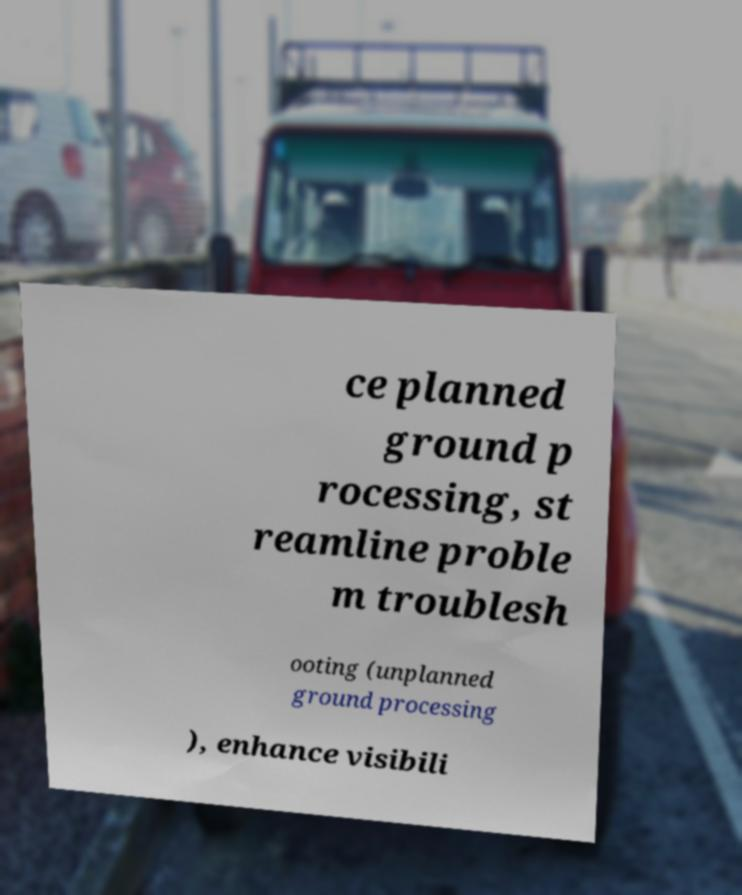What messages or text are displayed in this image? I need them in a readable, typed format. ce planned ground p rocessing, st reamline proble m troublesh ooting (unplanned ground processing ), enhance visibili 